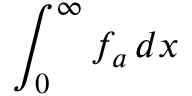Convert formula to latex. <formula><loc_0><loc_0><loc_500><loc_500>\int _ { 0 } ^ { \infty } f _ { a } \, d x</formula> 